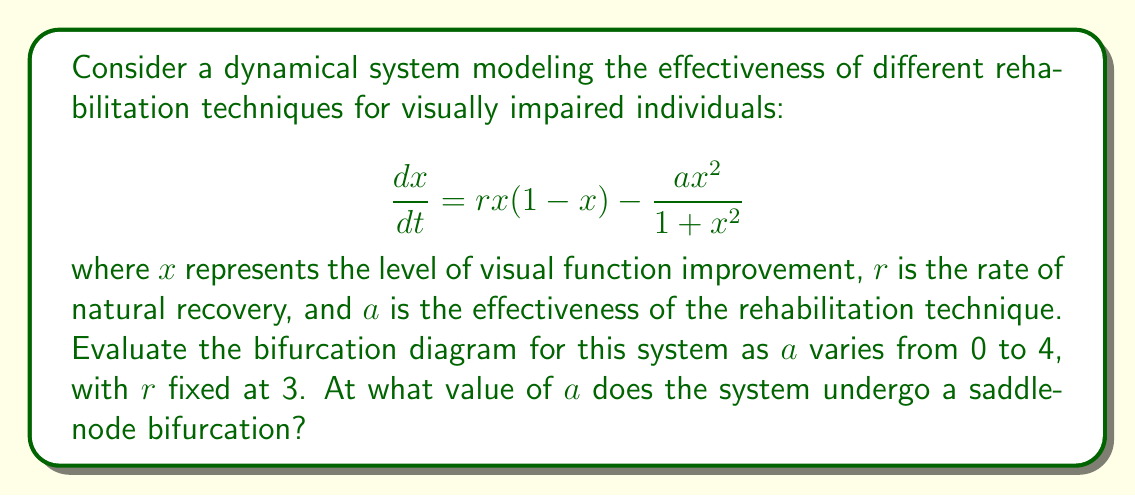Can you answer this question? To evaluate the bifurcation diagram and find the saddle-node bifurcation point, we follow these steps:

1) First, find the equilibrium points by setting $\frac{dx}{dt} = 0$:

   $$rx(1-x) - \frac{ax^2}{1+x^2} = 0$$

2) Substitute $r=3$ and rearrange:

   $$3x(1-x)(1+x^2) = ax^2$$
   $$3x + 3x^3 - 3x^2 - 3x^4 = ax^2$$
   $$3x^3 - (a+3)x^2 + 3x = 0$$

3) Factor out $x$:

   $$x(3x^2 - (a+3)x + 3) = 0$$

4) One equilibrium is always at $x=0$. For the other equilibria, solve:

   $$3x^2 - (a+3)x + 3 = 0$$

5) This is a quadratic equation. The saddle-node bifurcation occurs when this quadratic has exactly one solution, i.e., when its discriminant is zero:

   $$\Delta = (a+3)^2 - 4(3)(3) = 0$$

6) Solve this equation for $a$:

   $$a^2 + 6a + 9 - 36 = 0$$
   $$a^2 + 6a - 27 = 0$$

7) Using the quadratic formula:

   $$a = \frac{-6 \pm \sqrt{36 + 108}}{2} = \frac{-6 \pm \sqrt{144}}{2} = \frac{-6 \pm 12}{2}$$

8) The positive solution is:

   $$a = \frac{-6 + 12}{2} = 3$$

Therefore, the system undergoes a saddle-node bifurcation when $a = 3$.
Answer: $a = 3$ 